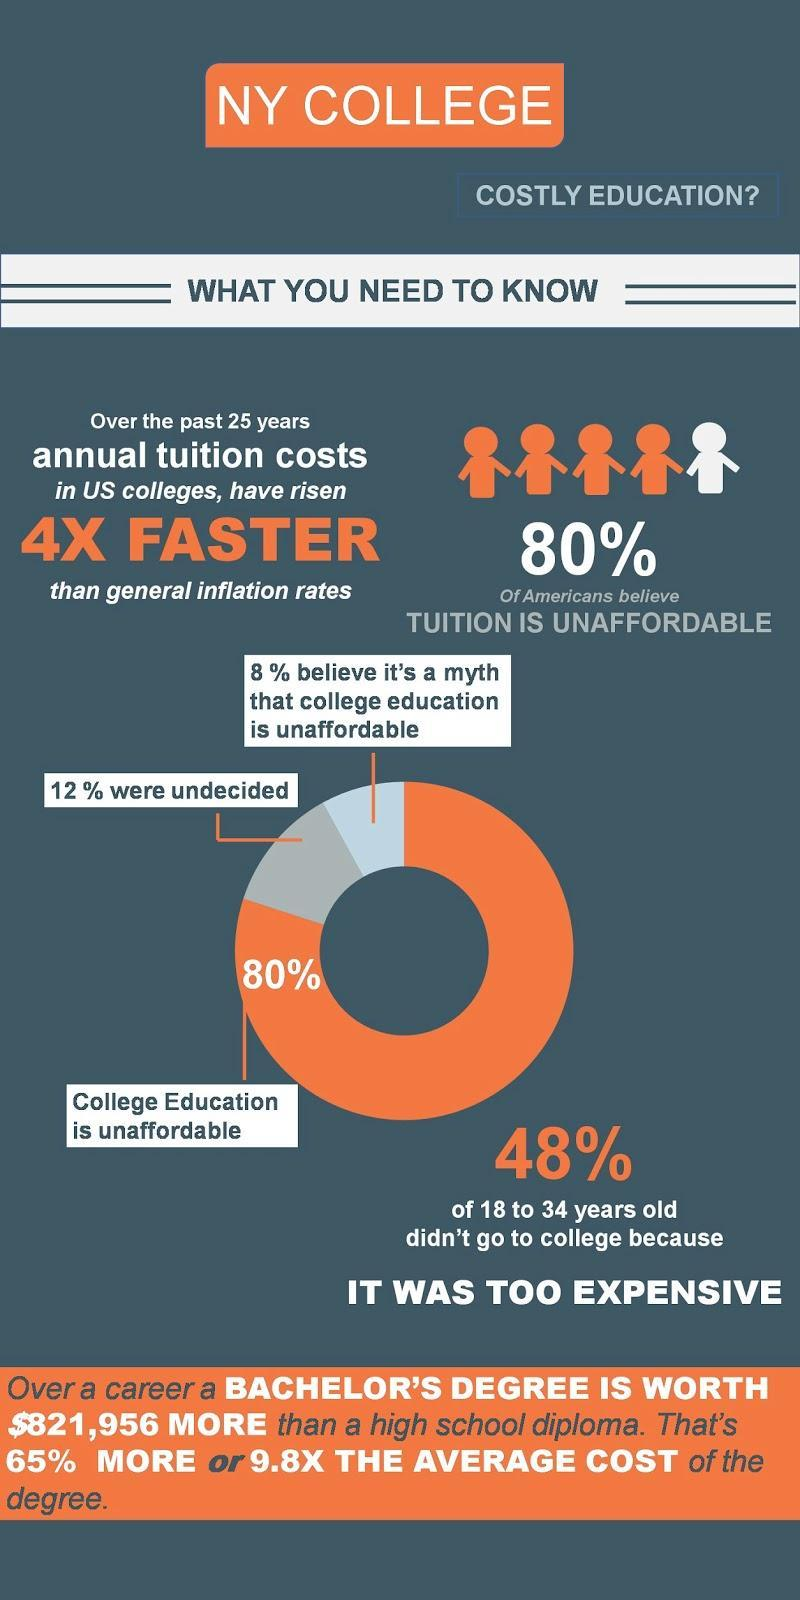What percentage of Americans believe that college education is unaffordable?
Answer the question with a short phrase. 80% 